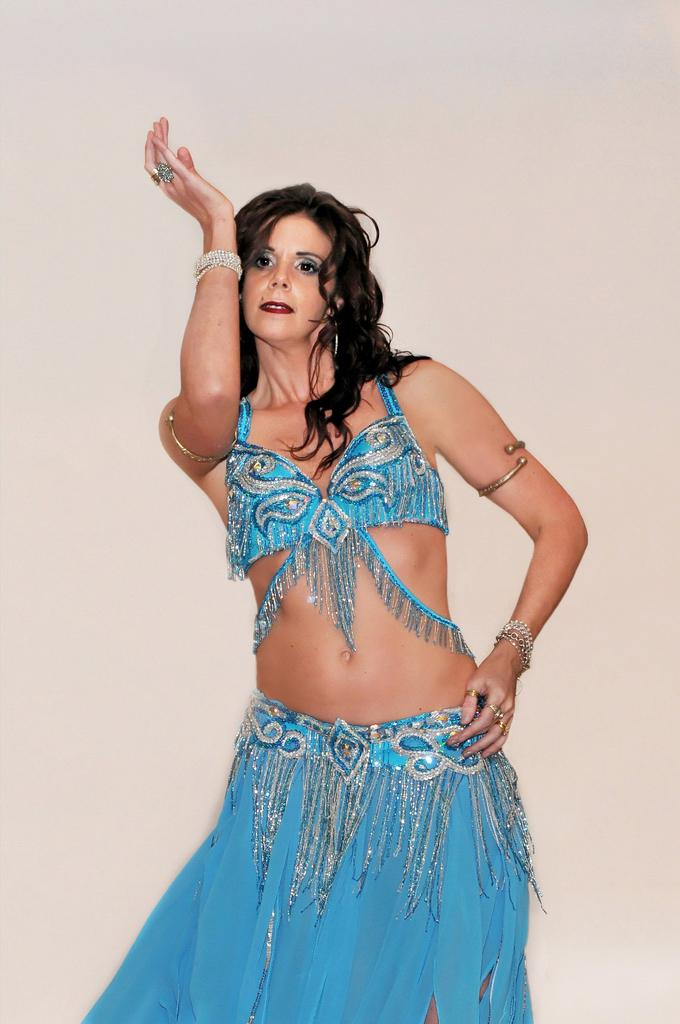Who is the main subject in the image? There is a woman in the image. Where is the woman positioned in the image? The woman is standing in the center of the image. What is the woman wearing in the image? The woman is wearing a blue dress and other jewelry. What type of party is the woman attending in the image? There is no indication of a party in the image; it only shows a woman standing in the center wearing a blue dress and other jewelry. 